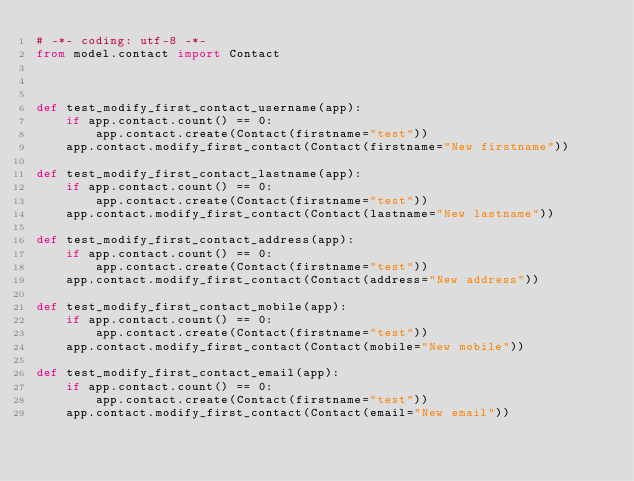<code> <loc_0><loc_0><loc_500><loc_500><_Python_># -*- coding: utf-8 -*-
from model.contact import Contact



def test_modify_first_contact_username(app):
    if app.contact.count() == 0:
        app.contact.create(Contact(firstname="test"))
    app.contact.modify_first_contact(Contact(firstname="New firstname"))

def test_modify_first_contact_lastname(app):
    if app.contact.count() == 0:
        app.contact.create(Contact(firstname="test"))
    app.contact.modify_first_contact(Contact(lastname="New lastname"))

def test_modify_first_contact_address(app):
    if app.contact.count() == 0:
        app.contact.create(Contact(firstname="test"))
    app.contact.modify_first_contact(Contact(address="New address"))

def test_modify_first_contact_mobile(app):
    if app.contact.count() == 0:
        app.contact.create(Contact(firstname="test"))
    app.contact.modify_first_contact(Contact(mobile="New mobile"))

def test_modify_first_contact_email(app):
    if app.contact.count() == 0:
        app.contact.create(Contact(firstname="test"))
    app.contact.modify_first_contact(Contact(email="New email"))
</code> 